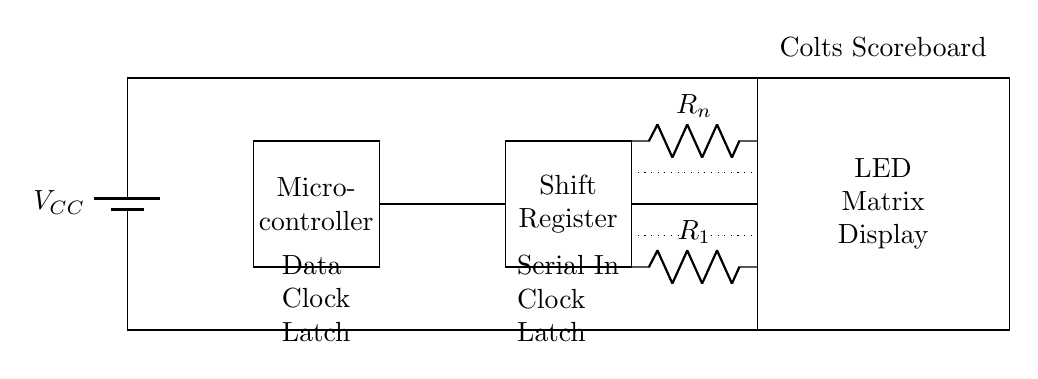What component represents the power supply? The power supply is represented by a battery icon labeled V_CC, indicating the source of voltage for the circuit.
Answer: V_CC What type of controller is shown in the circuit? The controller is shown as a rectangle labeled Micro-controller, which indicates that it processes data and sends signals to other components.
Answer: Micro-controller How many shift registers are present in the circuit? There is one shift register illustrated as a rectangle next to the micro-controller, indicating it also plays a role in data handling for the LED matrix.
Answer: One What is the function of R_1 and R_n? R_1 and R_n are current limiting resistors that are used to control the flow of current to the LED components in the matrix display, protecting them from excessive current.
Answer: Current limiting resistors What do the dotted lines in the circuit indicate? The dotted lines suggest that multiple resistors can be connected in a similar manner, indicating a pattern for adding additional current limiting resistors for more LED connections.
Answer: Multiple resistors What does the circuit connect to for powering the LED display? The circuit is connected to the power supply at the top (labeled V_CC) and also establishes a ground connection at the bottom to complete the circuit.
Answer: Power supply and ground 